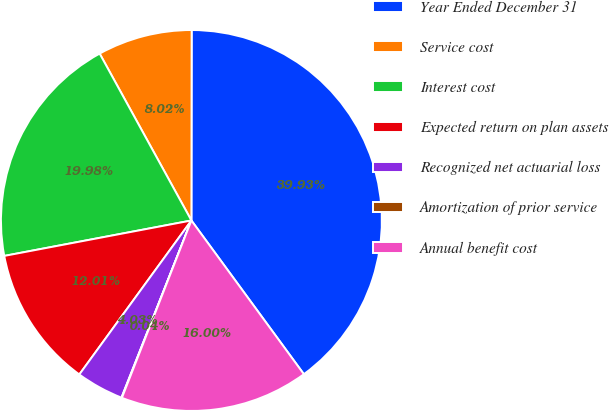Convert chart. <chart><loc_0><loc_0><loc_500><loc_500><pie_chart><fcel>Year Ended December 31<fcel>Service cost<fcel>Interest cost<fcel>Expected return on plan assets<fcel>Recognized net actuarial loss<fcel>Amortization of prior service<fcel>Annual benefit cost<nl><fcel>39.93%<fcel>8.02%<fcel>19.98%<fcel>12.01%<fcel>4.03%<fcel>0.04%<fcel>16.0%<nl></chart> 